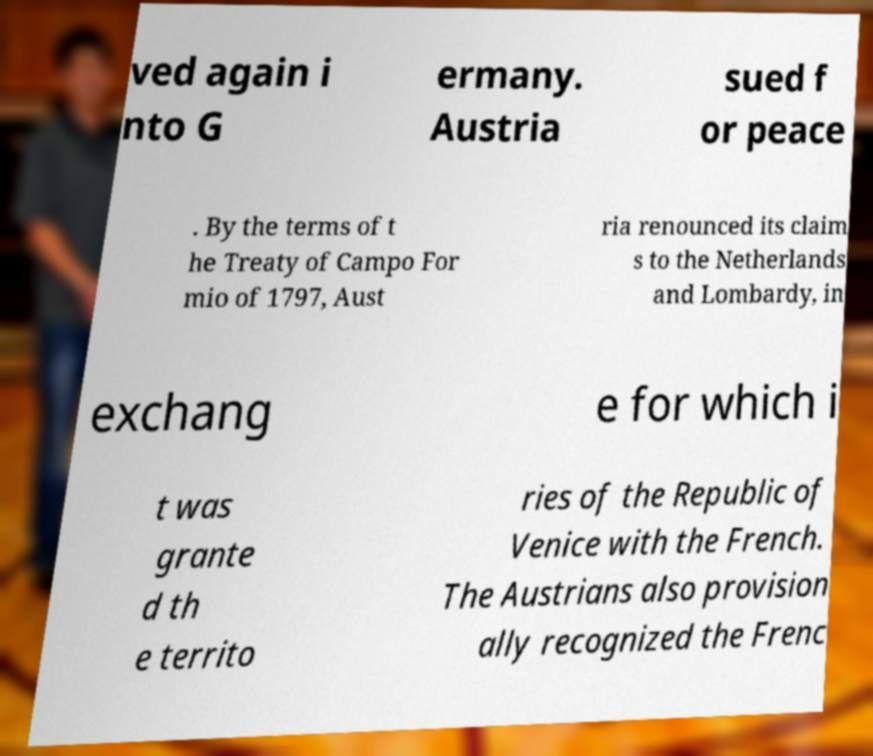Could you assist in decoding the text presented in this image and type it out clearly? ved again i nto G ermany. Austria sued f or peace . By the terms of t he Treaty of Campo For mio of 1797, Aust ria renounced its claim s to the Netherlands and Lombardy, in exchang e for which i t was grante d th e territo ries of the Republic of Venice with the French. The Austrians also provision ally recognized the Frenc 